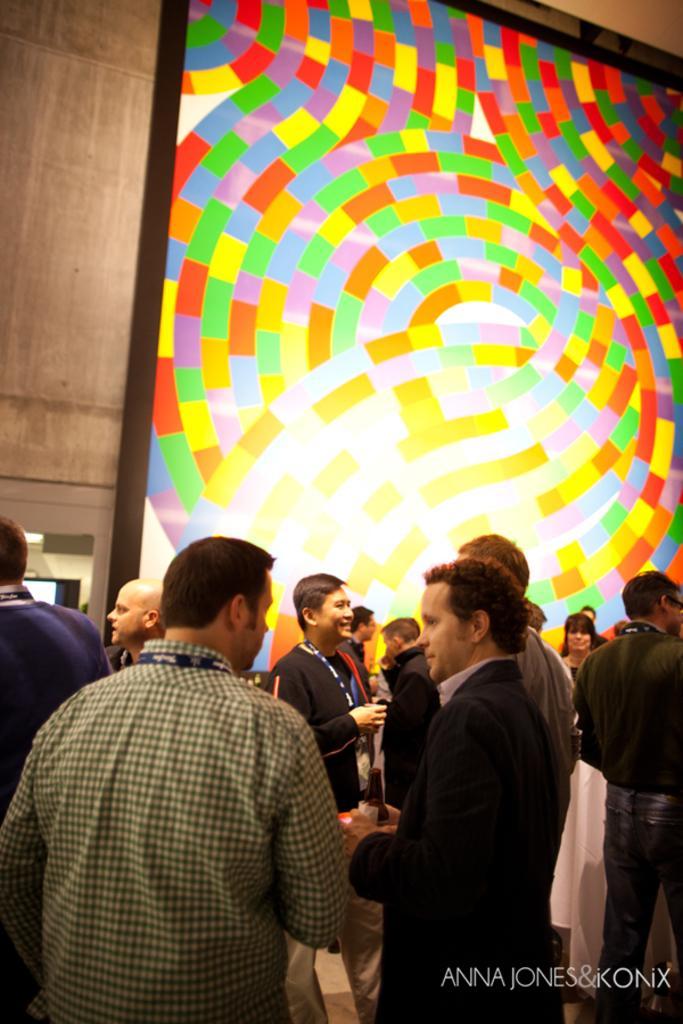Could you give a brief overview of what you see in this image? In this image we can see a group of people standing and behind them there is a colorful poster on the wall, on the bottom right corner of the image there is some text. 